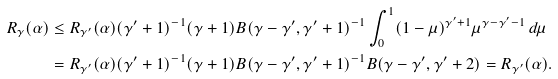<formula> <loc_0><loc_0><loc_500><loc_500>R _ { \gamma } ( \alpha ) & \leq R _ { \gamma ^ { \prime } } ( \alpha ) ( \gamma ^ { \prime } + 1 ) ^ { - 1 } ( \gamma + 1 ) B ( \gamma - \gamma ^ { \prime } , \gamma ^ { \prime } + 1 ) ^ { - 1 } \int _ { 0 } ^ { 1 } ( 1 - \mu ) ^ { \gamma ^ { \prime } + 1 } \mu ^ { \gamma - \gamma ^ { \prime } - 1 } \, d \mu \\ & = R _ { \gamma ^ { \prime } } ( \alpha ) ( \gamma ^ { \prime } + 1 ) ^ { - 1 } ( \gamma + 1 ) B ( \gamma - \gamma ^ { \prime } , \gamma ^ { \prime } + 1 ) ^ { - 1 } B ( \gamma - \gamma ^ { \prime } , \gamma ^ { \prime } + 2 ) = R _ { \gamma ^ { \prime } } ( \alpha ) .</formula> 